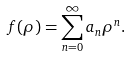<formula> <loc_0><loc_0><loc_500><loc_500>f ( \rho ) = \sum ^ { \infty } _ { n = 0 } a _ { n } \rho ^ { n } .</formula> 